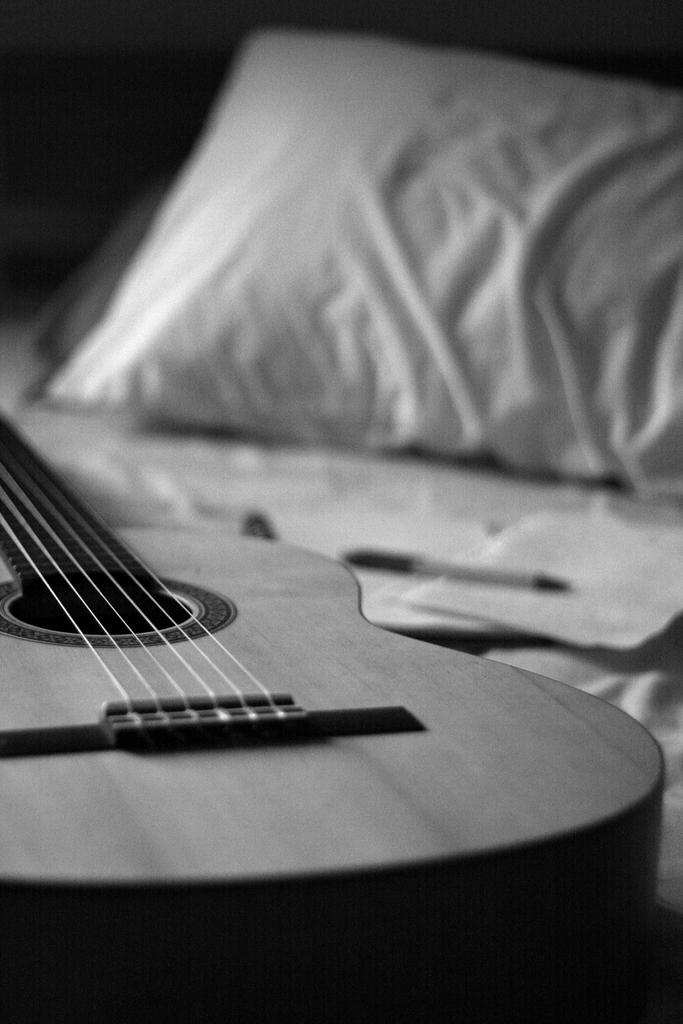What is the main object in the image? There is a guitar in the image. Where is the guitar located? The guitar is on a bed. What type of vacation is the guitar taking in the image? The guitar is not taking a vacation, as it is an inanimate object and cannot travel or experience vacations. 